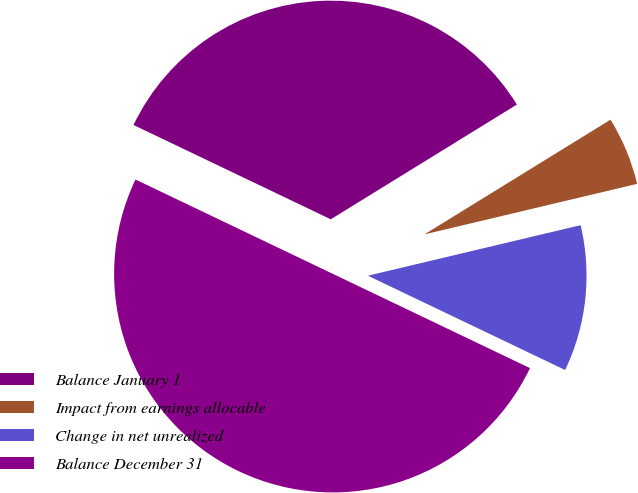Convert chart. <chart><loc_0><loc_0><loc_500><loc_500><pie_chart><fcel>Balance January 1<fcel>Impact from earnings allocable<fcel>Change in net unrealized<fcel>Balance December 31<nl><fcel>34.11%<fcel>5.08%<fcel>10.81%<fcel>50.0%<nl></chart> 